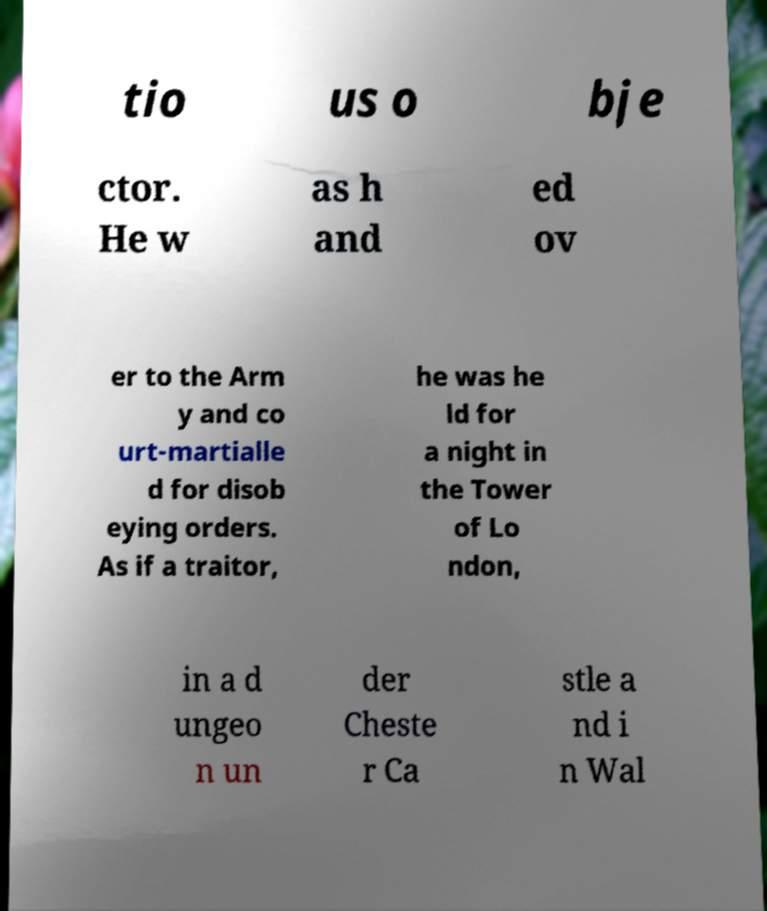Can you read and provide the text displayed in the image?This photo seems to have some interesting text. Can you extract and type it out for me? tio us o bje ctor. He w as h and ed ov er to the Arm y and co urt-martialle d for disob eying orders. As if a traitor, he was he ld for a night in the Tower of Lo ndon, in a d ungeo n un der Cheste r Ca stle a nd i n Wal 